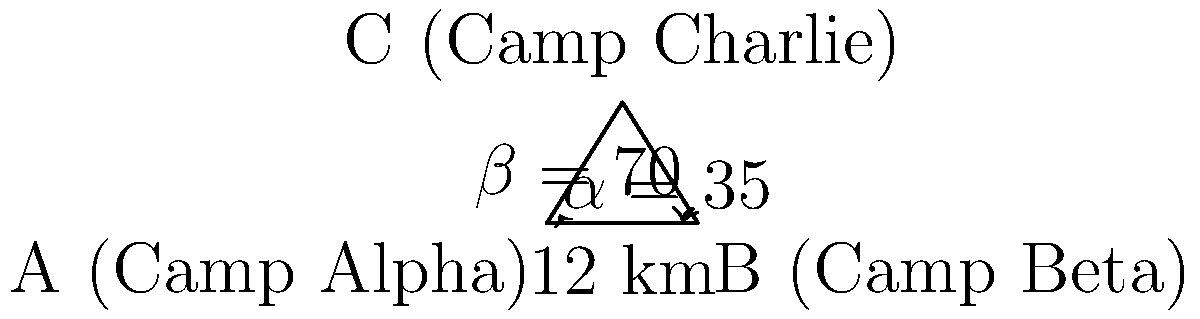In a conflict region, three refugee camps (Alpha, Beta, and Charlie) form a triangle. The distance between Camp Alpha and Camp Beta is 12 km. The angle at Camp Alpha (α) is 35°, and the angle at Camp Beta (β) is 70°. Using the law of sines, calculate the distance between Camp Alpha and Camp Charlie to the nearest tenth of a kilometer. To solve this problem, we'll use the law of sines. Let's follow these steps:

1) The law of sines states that for a triangle with sides a, b, c and opposite angles A, B, C:

   $$\frac{a}{\sin A} = \frac{b}{\sin B} = \frac{c}{\sin C}$$

2) In our case, we know:
   - Side c (between Alpha and Beta) = 12 km
   - Angle α (at Alpha) = 35°
   - Angle β (at Beta) = 70°

3) We need to find side a (between Alpha and Charlie). Let's call the angle at Charlie γ.

4) First, we need to find γ:
   $$\gamma = 180° - \alpha - \beta = 180° - 35° - 70° = 75°$$

5) Now we can use the law of sines:

   $$\frac{a}{\sin 70°} = \frac{12}{\sin 75°}$$

6) Solve for a:

   $$a = \frac{12 \sin 70°}{\sin 75°}$$

7) Using a calculator:

   $$a = \frac{12 \times 0.9397}{\sin 0.9659} \approx 11.7 \text{ km}$$

Therefore, the distance between Camp Alpha and Camp Charlie is approximately 11.7 km.
Answer: 11.7 km 